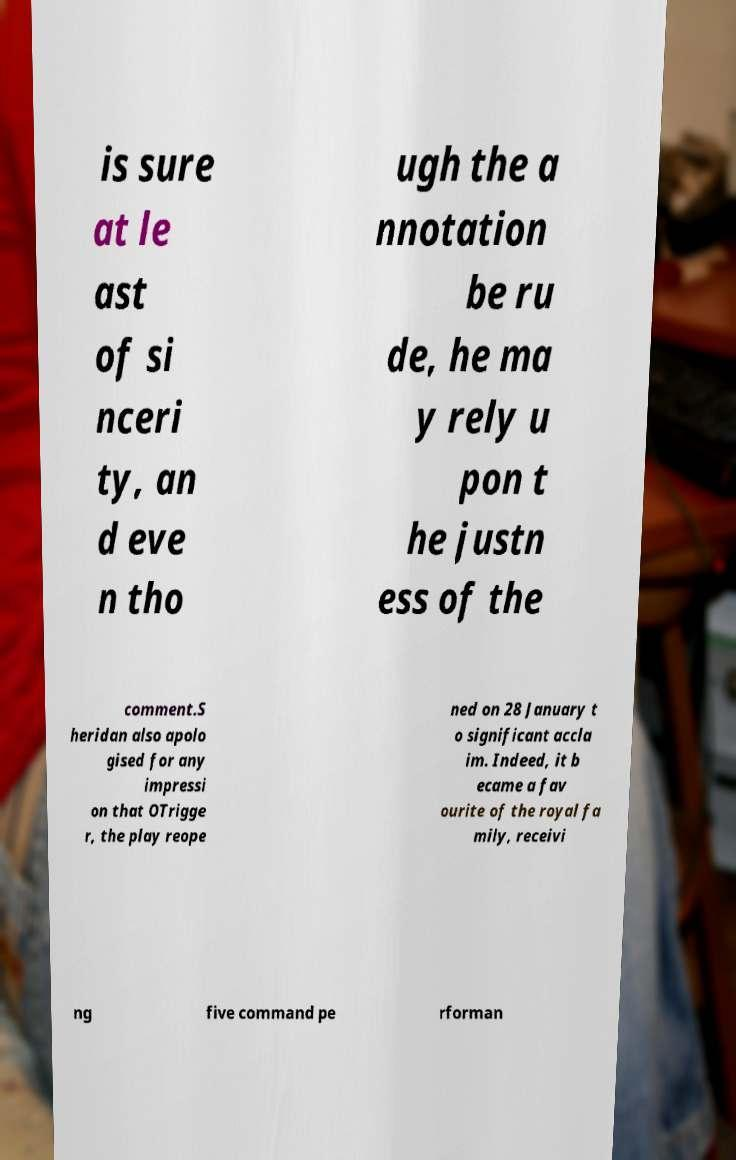I need the written content from this picture converted into text. Can you do that? is sure at le ast of si nceri ty, an d eve n tho ugh the a nnotation be ru de, he ma y rely u pon t he justn ess of the comment.S heridan also apolo gised for any impressi on that OTrigge r, the play reope ned on 28 January t o significant accla im. Indeed, it b ecame a fav ourite of the royal fa mily, receivi ng five command pe rforman 